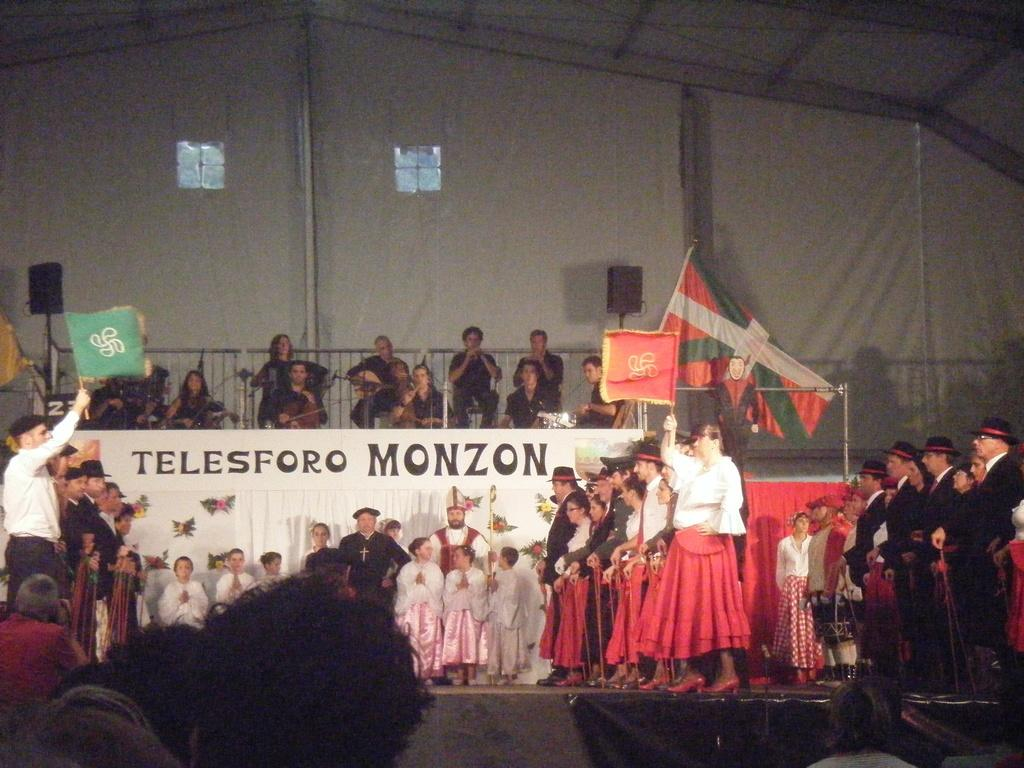How many people are in the image? There is a group of people in the image, but the exact number is not specified. What are some people doing in the image? Some people are holding flags in the image. What can be seen in the background of the image? There is a banner, speakers, and poles in the background of the image. What type of cable can be seen connecting the snails in the image? There are no snails or cables present in the image. 